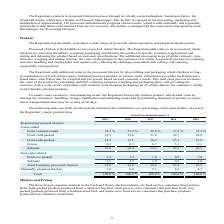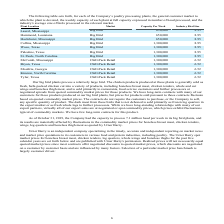From Sanderson Farms's financial document, What is the capacity per week for the plants at Laurel, Mississippi and Hammond, Louisiana respectively? The document shows two values: 650,000 and 650,000. From the document: "Laurel, Mississippi Big Bird 650,000 8.95..." Also, What is the capacity per week for the plants at Hazlehurst, Mississippi and Collins, Mississippi respectively? The document shows two values: 650,000 and 1,300,000. From the document: "Laurel, Mississippi Big Bird 650,000 8.95 Collins, Mississippi Big Bird 1,300,000 8.95..." Also, What is the industry bird size processed for the plants at Laurel, Mississippi and Hammond, Louisiana respectively? The document shows two values: 8.95 and 8.95. From the document: "Laurel, Mississippi Big Bird 650,000 8.95..." Also, How many plant locations have a capacity per week of 650,000? Counting the relevant items in the document: Laurel, Mississippi ,  Hammond, Louisiana ,  Hazlehurst, Mississippi, I find 3 instances. The key data points involved are: Hammond, Louisiana, Hazlehurst, Mississippi, Laurel, Mississippi. Also, can you calculate: What is the difference in capacity per week between the processing plants at Laurel, Mississippi and Collins, Mississippi?  Based on the calculation: 1,300,000-650,000, the result is 650000. This is based on the information: "Laurel, Mississippi Big Bird 650,000 8.95 Collins, Mississippi Big Bird 1,300,000 8.95..." The key data points involved are: 1,300,000, 650,000. Also, can you calculate: What is the difference in the industry bird size processed at Palestine, Texas compared to those at Bryan, Texas? Based on the calculation: 8.95-6.52, the result is 2.43. This is based on the information: "Laurel, Mississippi Big Bird 650,000 8.95 McComb, Mississippi Chill-Pack Retail 1,300,000 6.52..." The key data points involved are: 6.52, 8.95. 